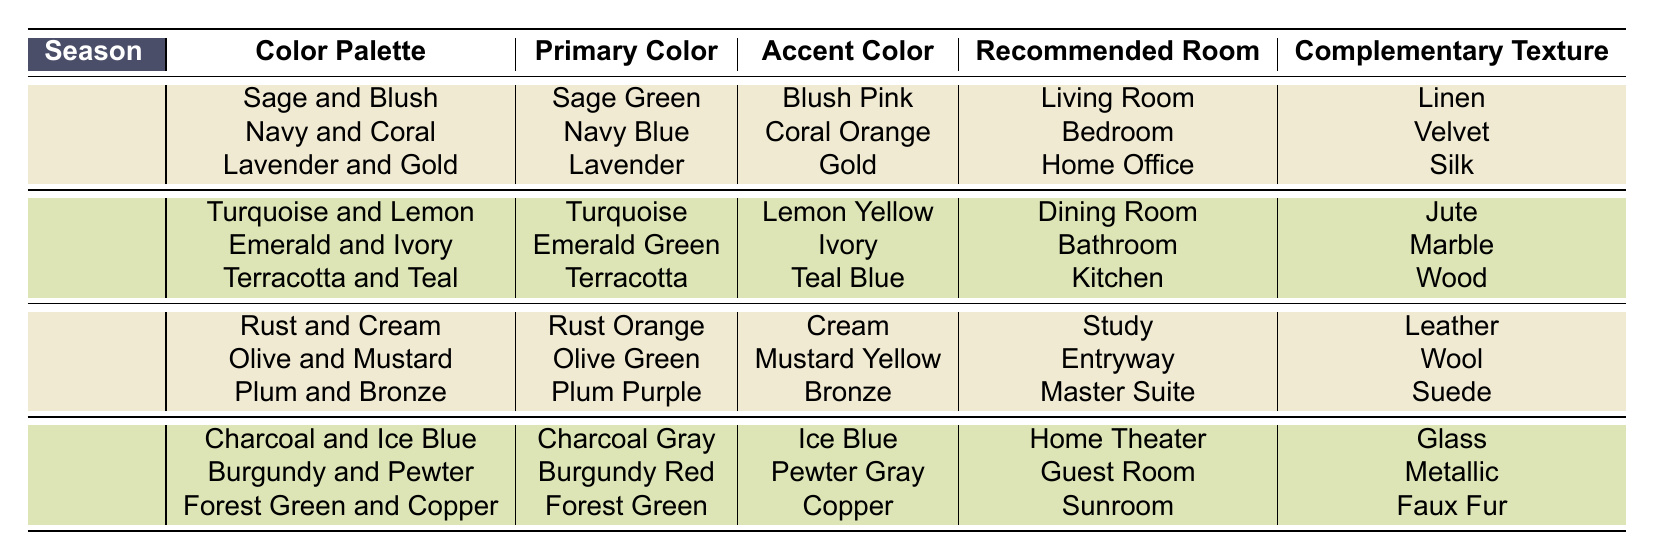What color palette is recommended for a bathroom in summer? The table indicates that for summer, the color palette recommended for the bathroom is "Emerald and Ivory."
Answer: Emerald and Ivory Which season features "Plum and Bronze" as a color palette? The table shows that "Plum and Bronze" is listed under the fall season.
Answer: Fall What is the primary color used in the "Charcoal and Ice Blue" palette? The table lists "Charcoal Gray" as the primary color for the "Charcoal and Ice Blue" palette.
Answer: Charcoal Gray Is "Copper" an accent color used in winter? According to the table, "Copper" is listed as the accent color for the "Forest Green and Copper" palette in winter. Therefore, the answer is yes.
Answer: Yes Which primary color is associated with the "Emerald and Ivory" palette? The primary color associated with the "Emerald and Ivory" palette is "Emerald Green," as seen in the summer section of the table.
Answer: Emerald Green What texture is recommended for a dining room painted in the "Turquoise and Lemon" palette? The table specifies Jute as the complementary texture for the "Turquoise and Lemon" palette in the dining room.
Answer: Jute How many different recommended rooms are there for the spring season? The spring season has three recommended rooms: Living Room, Bedroom, and Home Office, as listed in the table. Therefore, the count is three.
Answer: 3 Which season has the most color palettes listed? By examining the table, we can see that there are three color palettes listed for spring, summer, fall, and winter each, indicating equal representation. Therefore, no single season has more than the others.
Answer: No single season What is the accent color for the "Rust and Cream" palette? The table shows that the accent color for the "Rust and Cream" palette is "Cream."
Answer: Cream In which room is the "Burgundy and Pewter" palette recommended? The table indicates that the "Burgundy and Pewter" palette is recommended for the guest room in winter.
Answer: Guest Room 